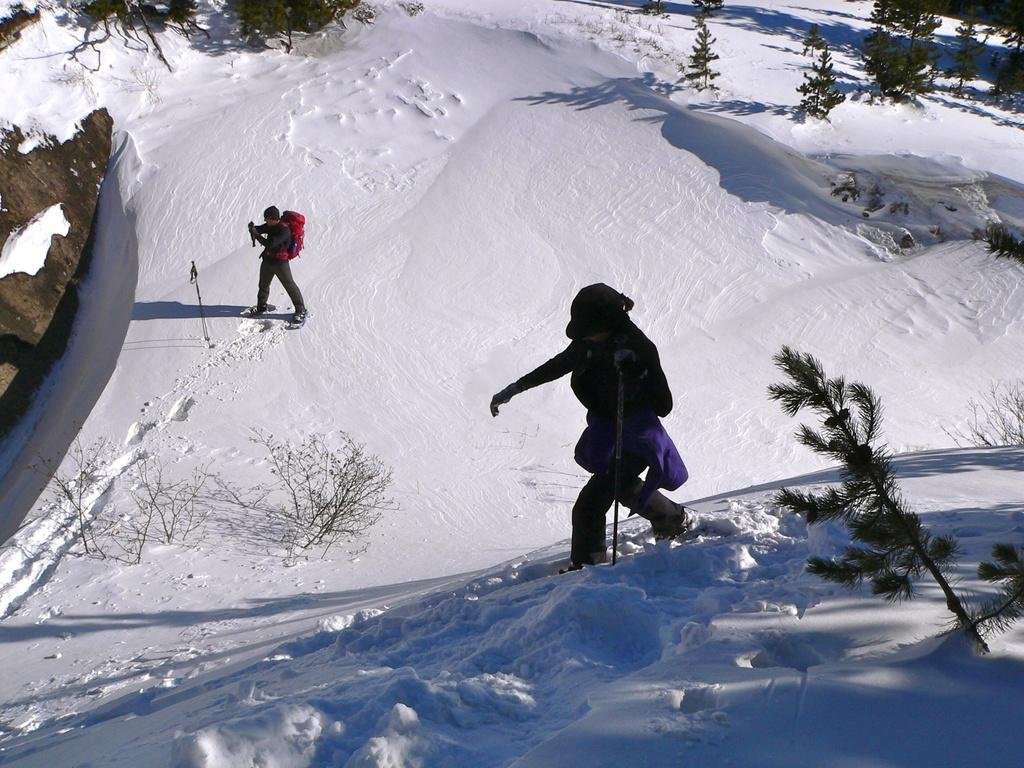How many people are present in the image? There are two people in the image, one standing and one walking. What is the setting of the image? The scene takes place in the snow. What type of vegetation can be seen in the image? There are trees present in the image. What type of pear can be seen floating in the harbor in the image? There is no pear or harbor present in the image; it takes place in the snow with trees. 